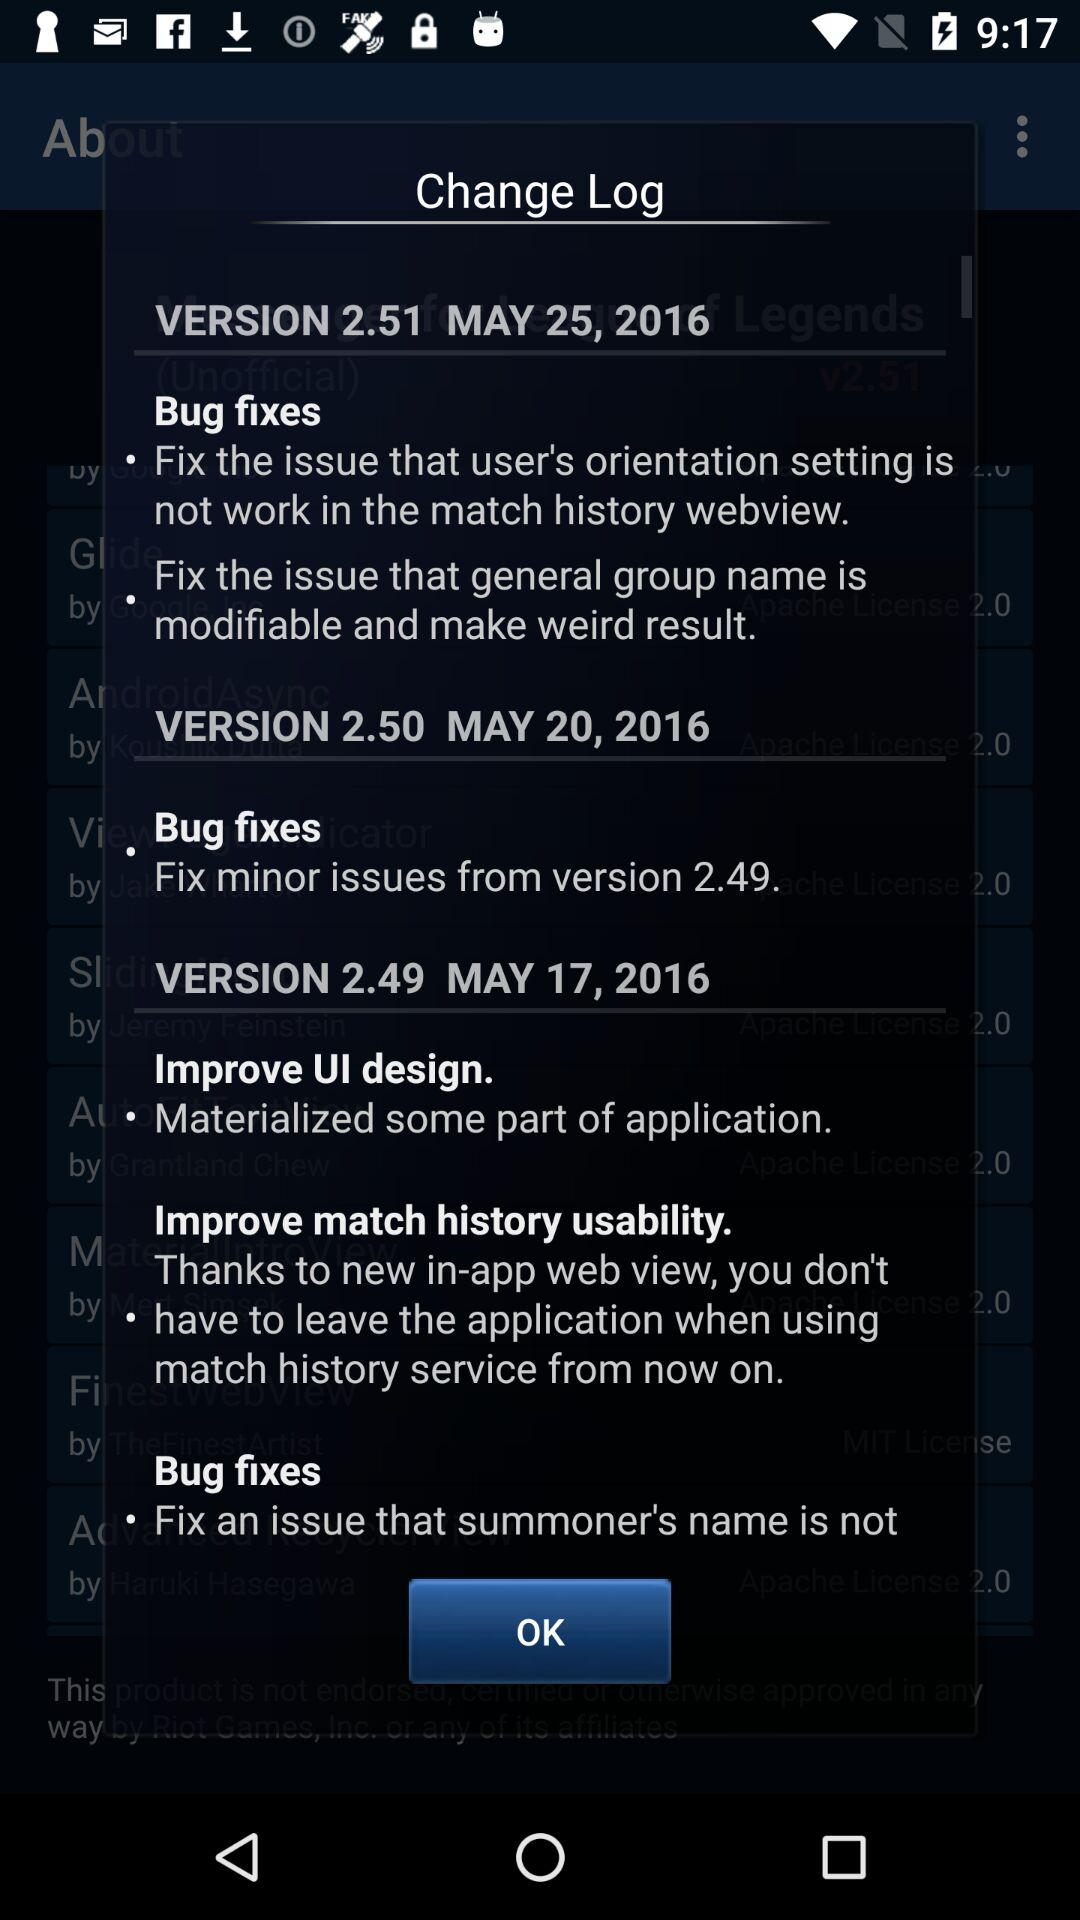How many bug fixes are there in version 2.51?
Answer the question using a single word or phrase. 2 